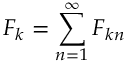Convert formula to latex. <formula><loc_0><loc_0><loc_500><loc_500>F _ { k } = \sum _ { n = 1 } ^ { \infty } F _ { k n }</formula> 